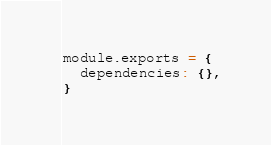Convert code to text. <code><loc_0><loc_0><loc_500><loc_500><_JavaScript_>module.exports = {
  dependencies: {},
}
</code> 